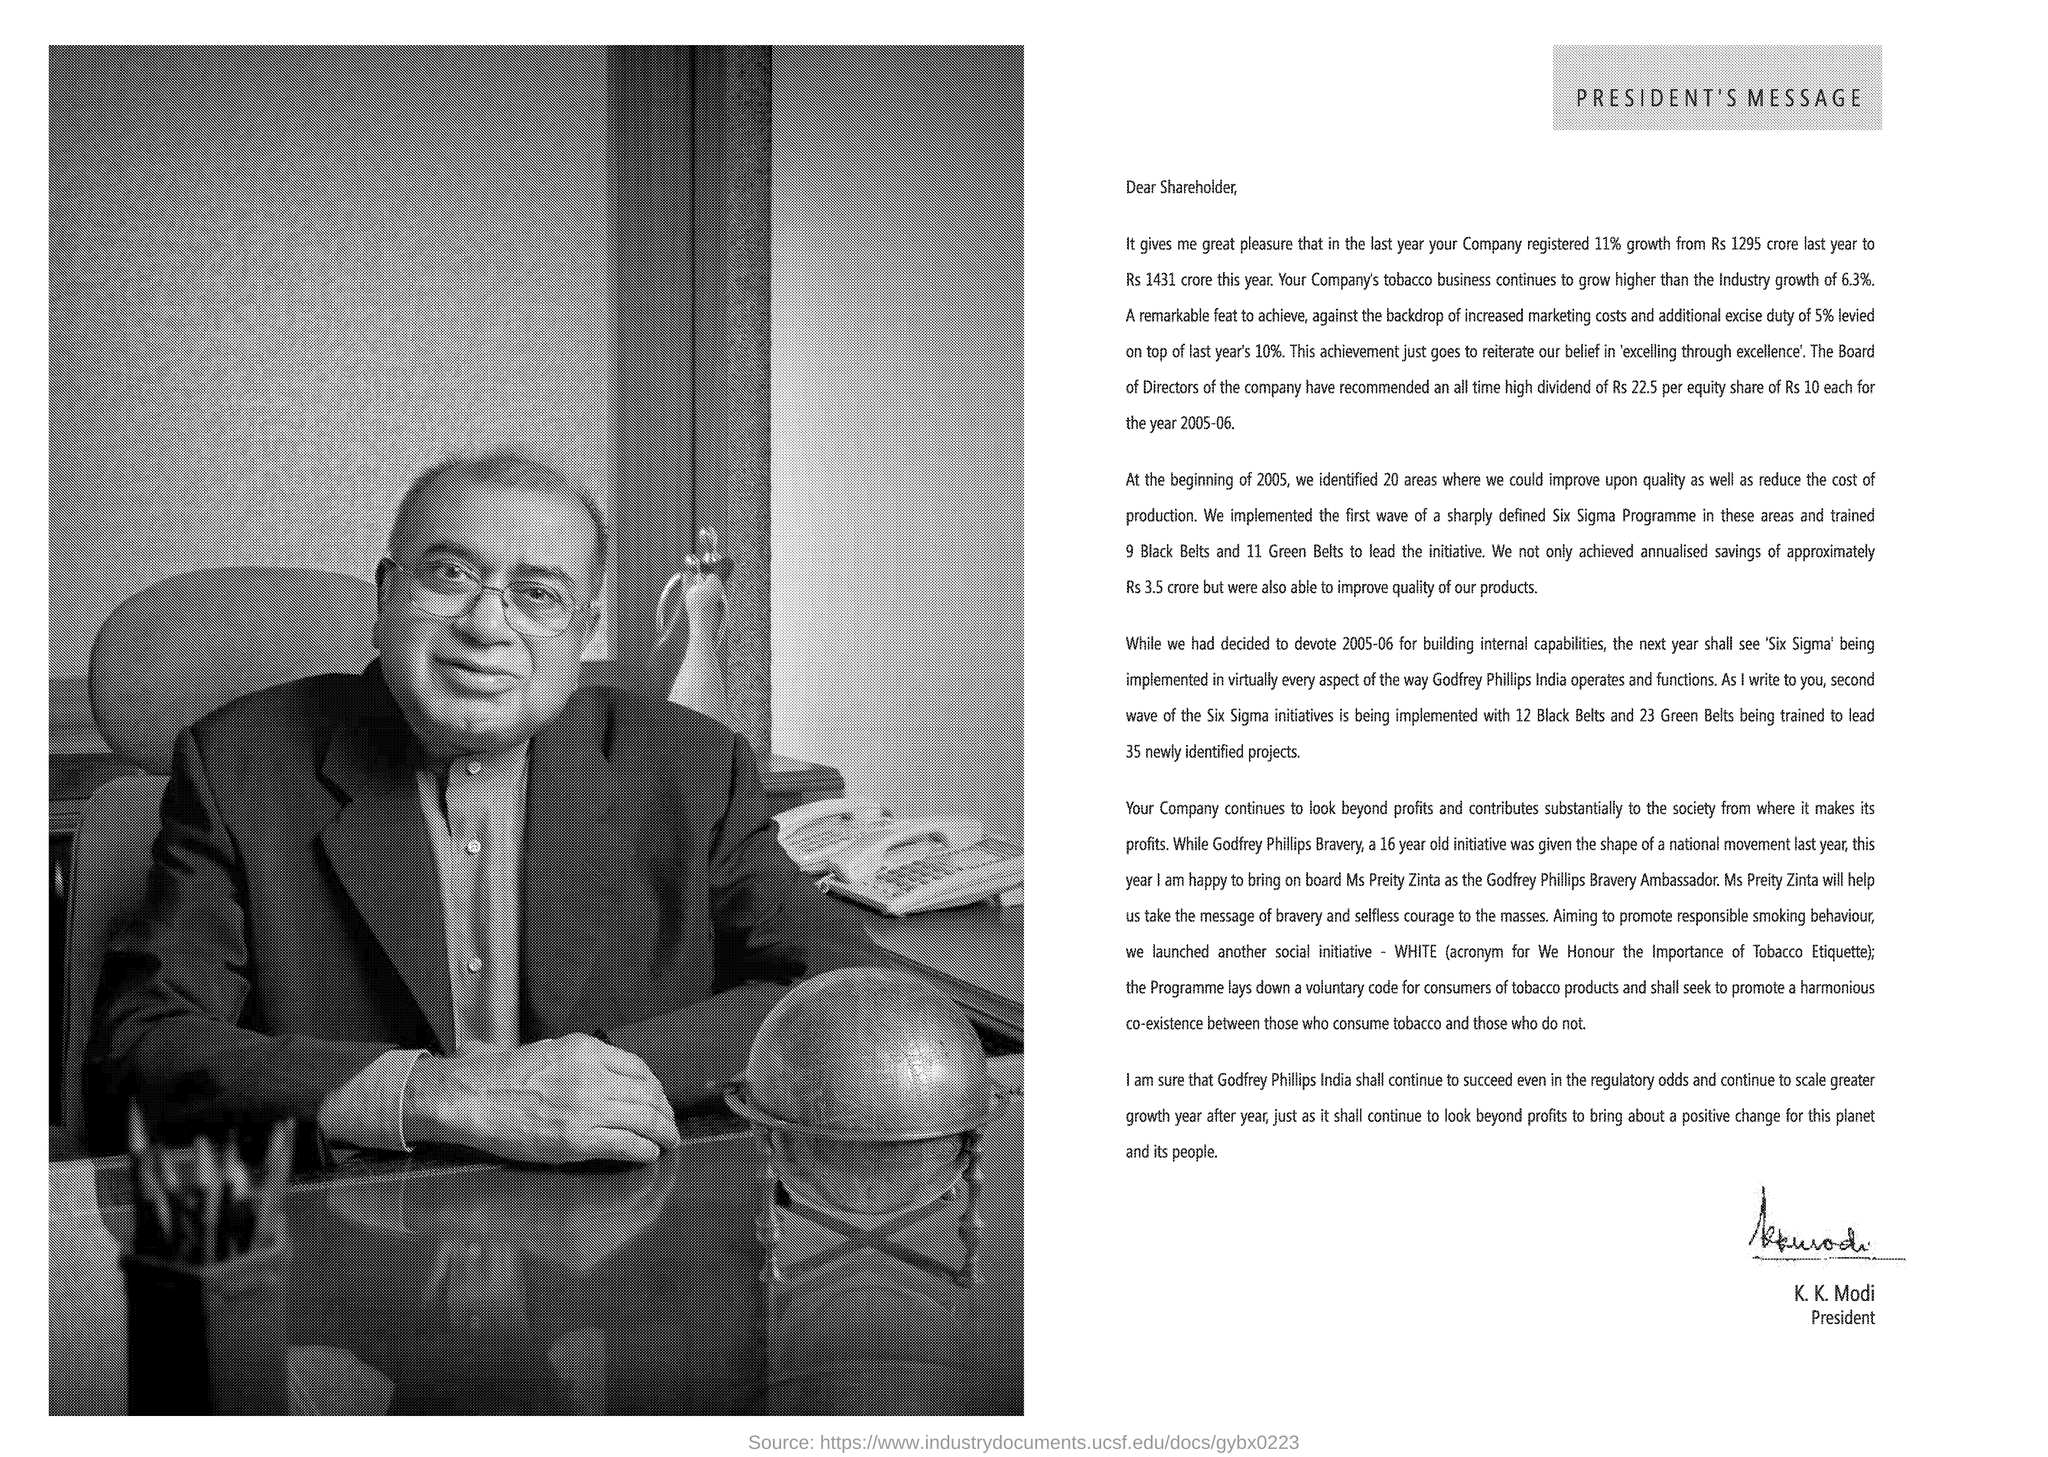Who is the President?
Make the answer very short. K. K. Modi. Who is the message addressed to?
Offer a very short reply. Shareholder. 